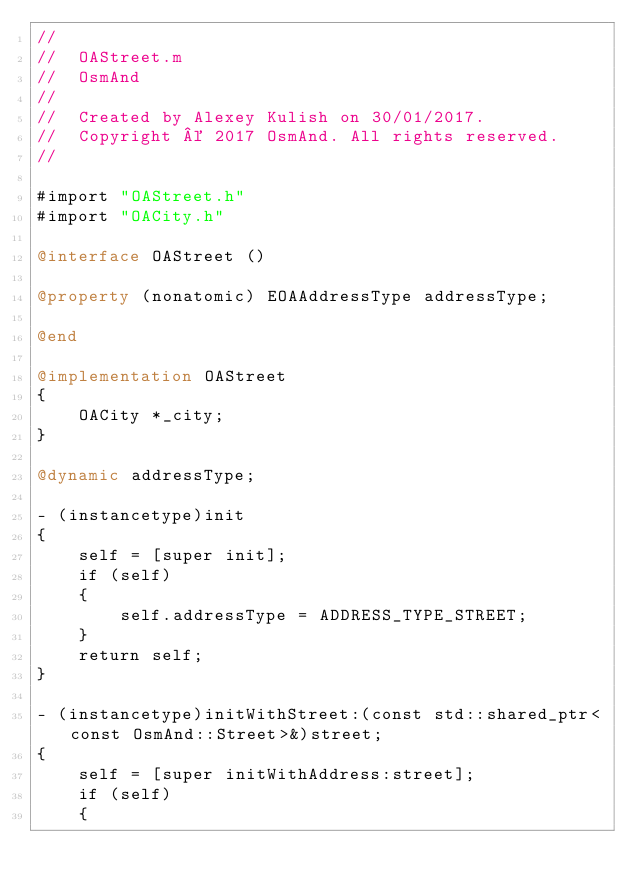Convert code to text. <code><loc_0><loc_0><loc_500><loc_500><_ObjectiveC_>//
//  OAStreet.m
//  OsmAnd
//
//  Created by Alexey Kulish on 30/01/2017.
//  Copyright © 2017 OsmAnd. All rights reserved.
//

#import "OAStreet.h"
#import "OACity.h"

@interface OAStreet ()

@property (nonatomic) EOAAddressType addressType;

@end

@implementation OAStreet
{
    OACity *_city;
}

@dynamic addressType;

- (instancetype)init
{
    self = [super init];
    if (self)
    {
        self.addressType = ADDRESS_TYPE_STREET;
    }
    return self;
}

- (instancetype)initWithStreet:(const std::shared_ptr<const OsmAnd::Street>&)street;
{
    self = [super initWithAddress:street];
    if (self)
    {</code> 